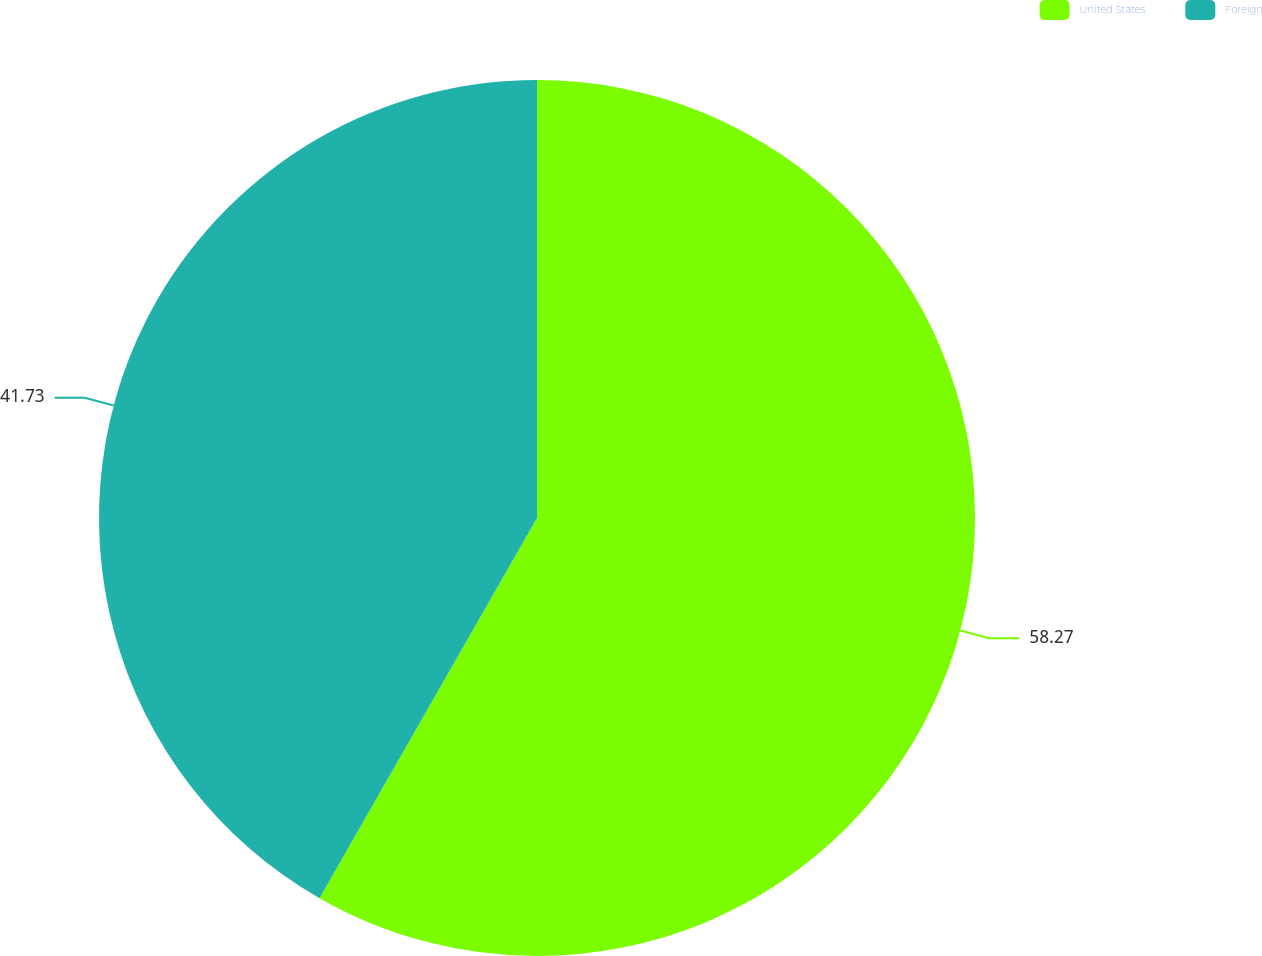<chart> <loc_0><loc_0><loc_500><loc_500><pie_chart><fcel>United States<fcel>Foreign<nl><fcel>58.27%<fcel>41.73%<nl></chart> 